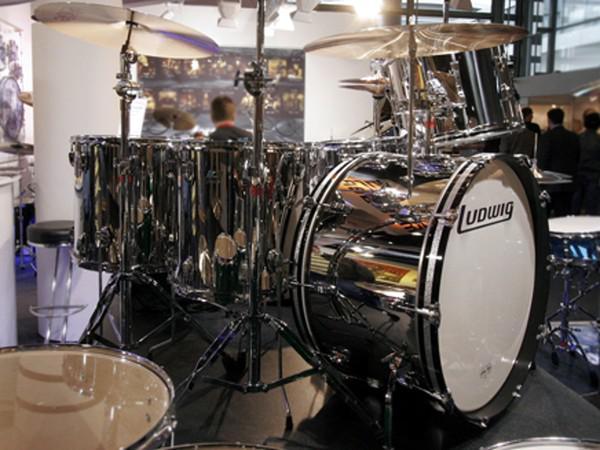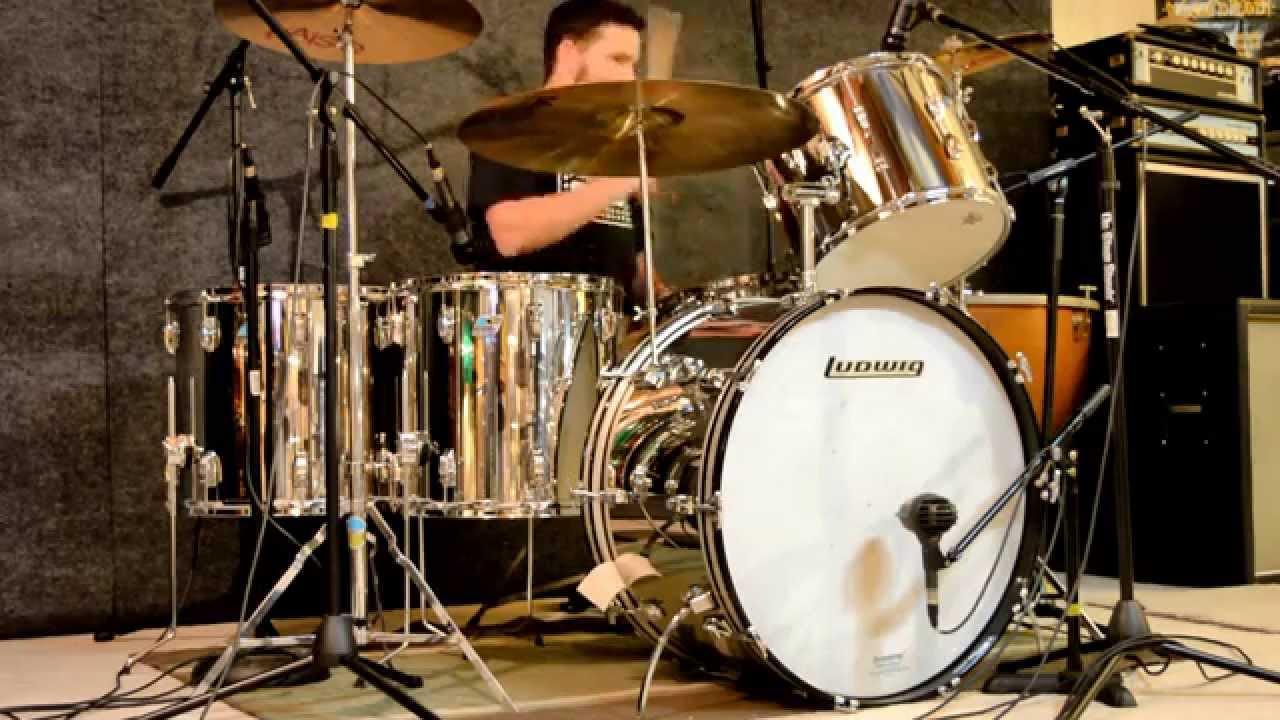The first image is the image on the left, the second image is the image on the right. Examine the images to the left and right. Is the description "In at least one image there is a man playing a sliver drum set that is facing forward right." accurate? Answer yes or no. Yes. The first image is the image on the left, the second image is the image on the right. Considering the images on both sides, is "The face of the large drum in the front is entirely visible in each image." valid? Answer yes or no. Yes. 